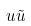Convert formula to latex. <formula><loc_0><loc_0><loc_500><loc_500>u \tilde { u }</formula> 